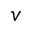<formula> <loc_0><loc_0><loc_500><loc_500>v</formula> 